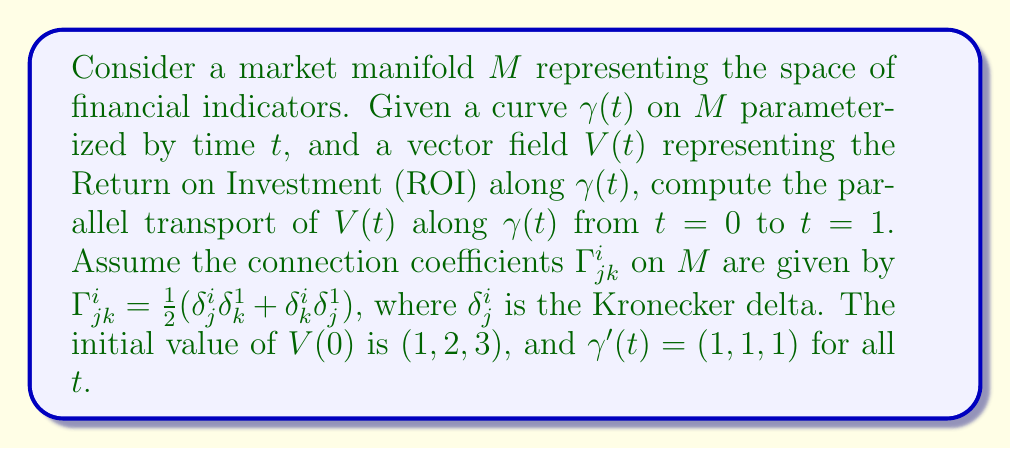Give your solution to this math problem. To compute the parallel transport of $V(t)$ along $\gamma(t)$, we need to solve the parallel transport equation:

$$\frac{dV^i}{dt} + \Gamma^i_{jk}V^j\frac{d\gamma^k}{dt} = 0$$

Given:
1. $\Gamma^i_{jk} = \frac{1}{2}(\delta^i_j\delta_k^1 + \delta^i_k\delta_j^1)$
2. $V(0) = (1, 2, 3)$
3. $\gamma'(t) = (1, 1, 1)$

Step 1: Expand the parallel transport equation for each component $i = 1, 2, 3$:

For $i = 1$:
$$\frac{dV^1}{dt} + \frac{1}{2}(V^1 \cdot 1 + V^1 \cdot 1) = 0$$
$$\frac{dV^1}{dt} + V^1 = 0$$

For $i = 2$:
$$\frac{dV^2}{dt} + \frac{1}{2}(V^1 \cdot 1 + V^2 \cdot 1) = 0$$
$$\frac{dV^2}{dt} + \frac{1}{2}(V^1 + V^2) = 0$$

For $i = 3$:
$$\frac{dV^3}{dt} + \frac{1}{2}(V^1 \cdot 1 + V^3 \cdot 1) = 0$$
$$\frac{dV^3}{dt} + \frac{1}{2}(V^1 + V^3) = 0$$

Step 2: Solve the system of differential equations:

For $V^1$:
$$\frac{dV^1}{dt} + V^1 = 0$$
$$V^1(t) = V^1(0)e^{-t} = e^{-t}$$

For $V^2$:
$$\frac{dV^2}{dt} + \frac{1}{2}(e^{-t} + V^2) = 0$$
$$V^2(t) = 2e^{-t/2} - e^{-t}$$

For $V^3$:
$$\frac{dV^3}{dt} + \frac{1}{2}(e^{-t} + V^3) = 0$$
$$V^3(t) = 3e^{-t/2} - e^{-t}$$

Step 3: Evaluate $V(t)$ at $t = 1$:

$$V(1) = (e^{-1}, 2e^{-1/2} - e^{-1}, 3e^{-1/2} - e^{-1})$$
Answer: $(e^{-1}, 2e^{-1/2} - e^{-1}, 3e^{-1/2} - e^{-1})$ 